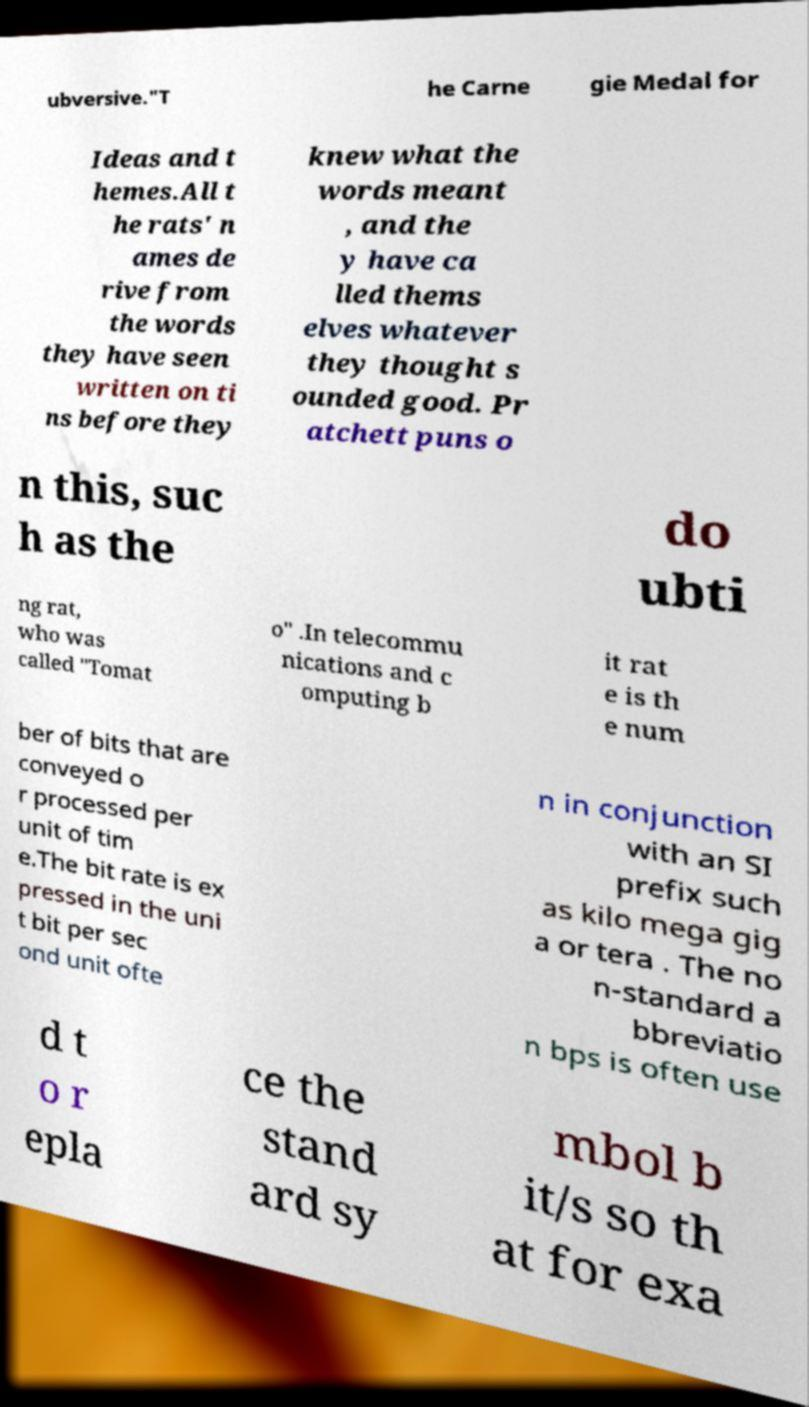For documentation purposes, I need the text within this image transcribed. Could you provide that? ubversive."T he Carne gie Medal for Ideas and t hemes.All t he rats' n ames de rive from the words they have seen written on ti ns before they knew what the words meant , and the y have ca lled thems elves whatever they thought s ounded good. Pr atchett puns o n this, suc h as the do ubti ng rat, who was called "Tomat o" .In telecommu nications and c omputing b it rat e is th e num ber of bits that are conveyed o r processed per unit of tim e.The bit rate is ex pressed in the uni t bit per sec ond unit ofte n in conjunction with an SI prefix such as kilo mega gig a or tera . The no n-standard a bbreviatio n bps is often use d t o r epla ce the stand ard sy mbol b it/s so th at for exa 